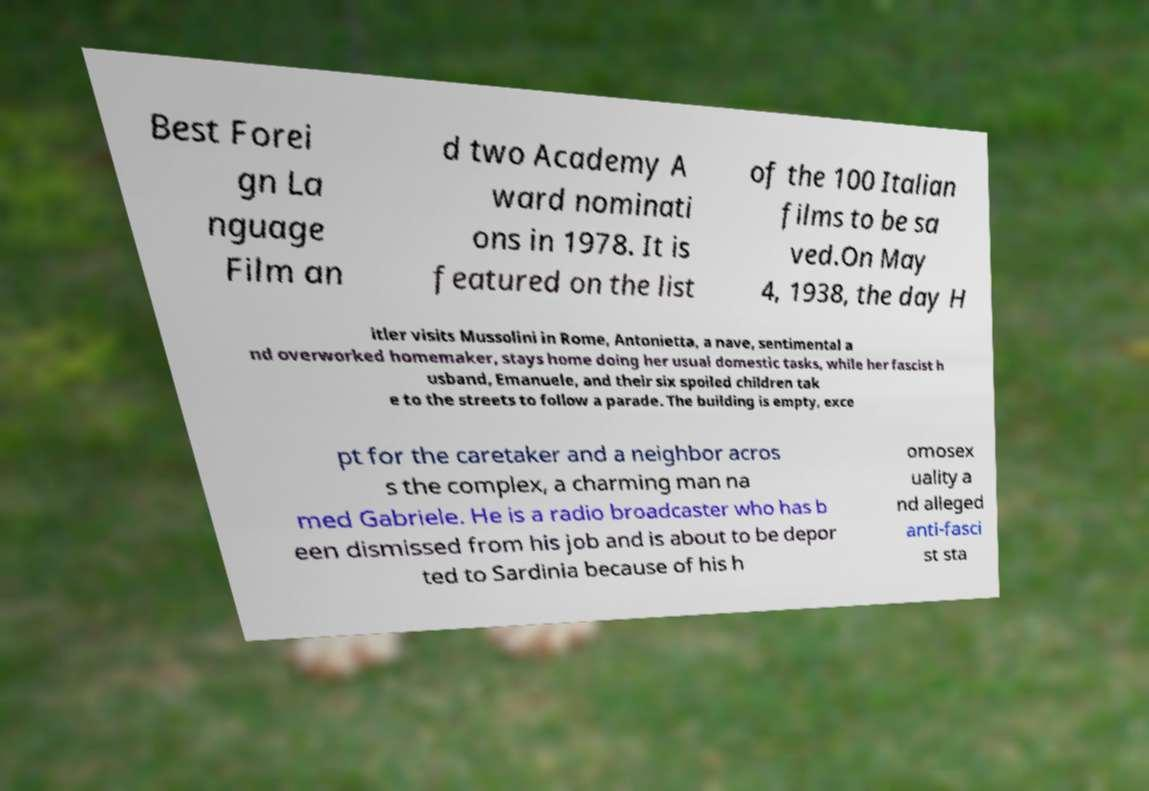Could you assist in decoding the text presented in this image and type it out clearly? Best Forei gn La nguage Film an d two Academy A ward nominati ons in 1978. It is featured on the list of the 100 Italian films to be sa ved.On May 4, 1938, the day H itler visits Mussolini in Rome, Antonietta, a nave, sentimental a nd overworked homemaker, stays home doing her usual domestic tasks, while her fascist h usband, Emanuele, and their six spoiled children tak e to the streets to follow a parade. The building is empty, exce pt for the caretaker and a neighbor acros s the complex, a charming man na med Gabriele. He is a radio broadcaster who has b een dismissed from his job and is about to be depor ted to Sardinia because of his h omosex uality a nd alleged anti-fasci st sta 